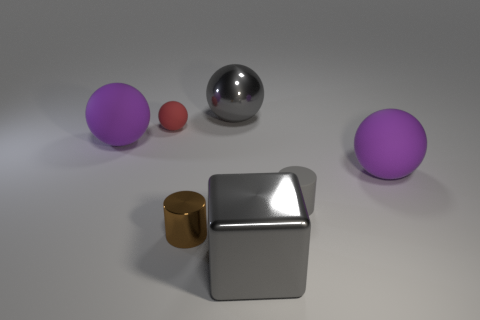What shape is the metal object that is the same color as the large block?
Your answer should be compact. Sphere. What color is the small matte thing right of the small red rubber ball?
Keep it short and to the point. Gray. Are there any other small things of the same shape as the brown thing?
Offer a terse response. Yes. Are there fewer small metal cylinders behind the small matte ball than small brown shiny things that are to the right of the large metallic sphere?
Give a very brief answer. No. The big shiny ball has what color?
Keep it short and to the point. Gray. There is a big thing that is on the left side of the small brown object; is there a rubber sphere on the left side of it?
Provide a short and direct response. No. How many purple rubber balls have the same size as the gray metallic ball?
Make the answer very short. 2. How many matte cylinders are left of the small cylinder that is on the left side of the large ball behind the tiny red rubber object?
Provide a short and direct response. 0. How many objects are behind the brown metal cylinder and on the right side of the shiny cylinder?
Make the answer very short. 3. Is there anything else of the same color as the shiny cylinder?
Your answer should be compact. No. 